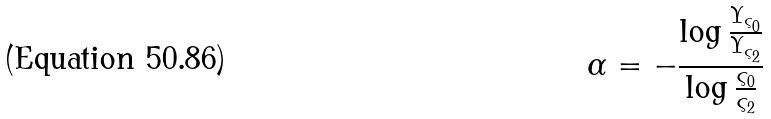Convert formula to latex. <formula><loc_0><loc_0><loc_500><loc_500>\alpha = - \frac { \log \frac { \Upsilon _ { \varsigma _ { 0 } } } { \Upsilon _ { \varsigma _ { 2 } } } } { \log \frac { \varsigma _ { 0 } } { \varsigma _ { 2 } } }</formula> 